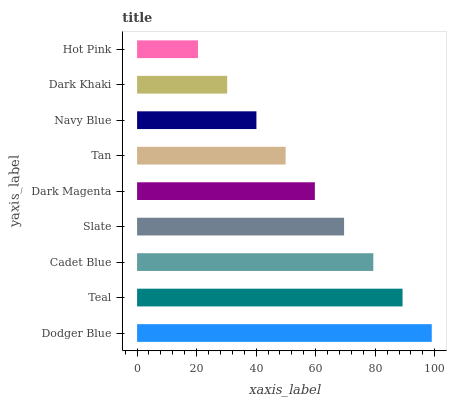Is Hot Pink the minimum?
Answer yes or no. Yes. Is Dodger Blue the maximum?
Answer yes or no. Yes. Is Teal the minimum?
Answer yes or no. No. Is Teal the maximum?
Answer yes or no. No. Is Dodger Blue greater than Teal?
Answer yes or no. Yes. Is Teal less than Dodger Blue?
Answer yes or no. Yes. Is Teal greater than Dodger Blue?
Answer yes or no. No. Is Dodger Blue less than Teal?
Answer yes or no. No. Is Dark Magenta the high median?
Answer yes or no. Yes. Is Dark Magenta the low median?
Answer yes or no. Yes. Is Dark Khaki the high median?
Answer yes or no. No. Is Navy Blue the low median?
Answer yes or no. No. 